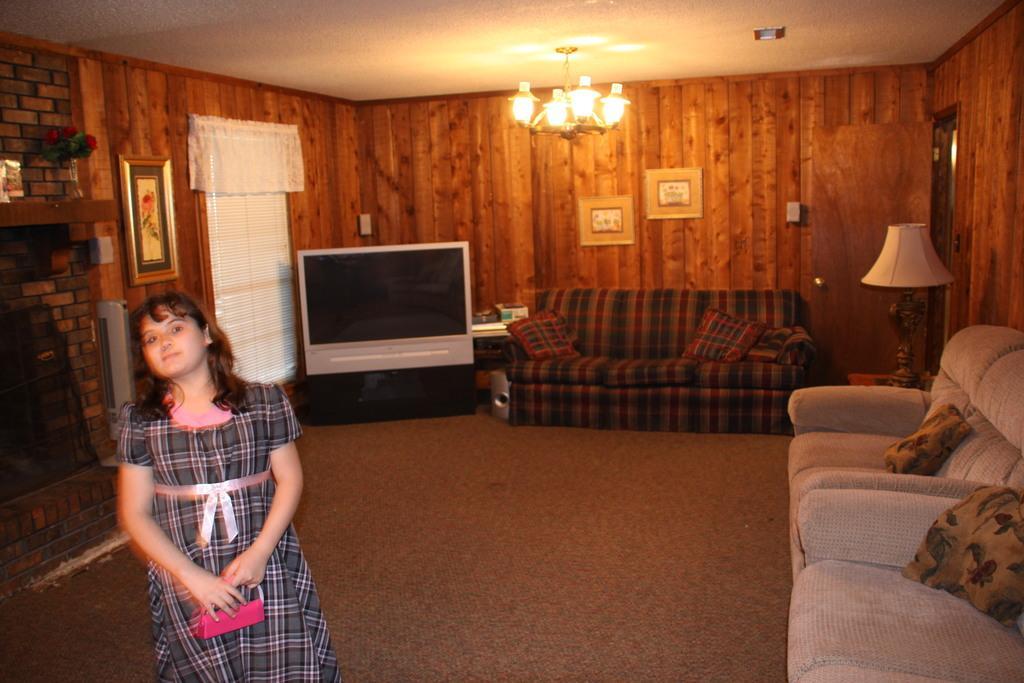Please provide a concise description of this image. In this picture there is a woman Standing and she is holding a bag in the right side we can see the couch and pillows on the couch back ground we can see the television and lighted lamp. there are some photo frames to the wall. 